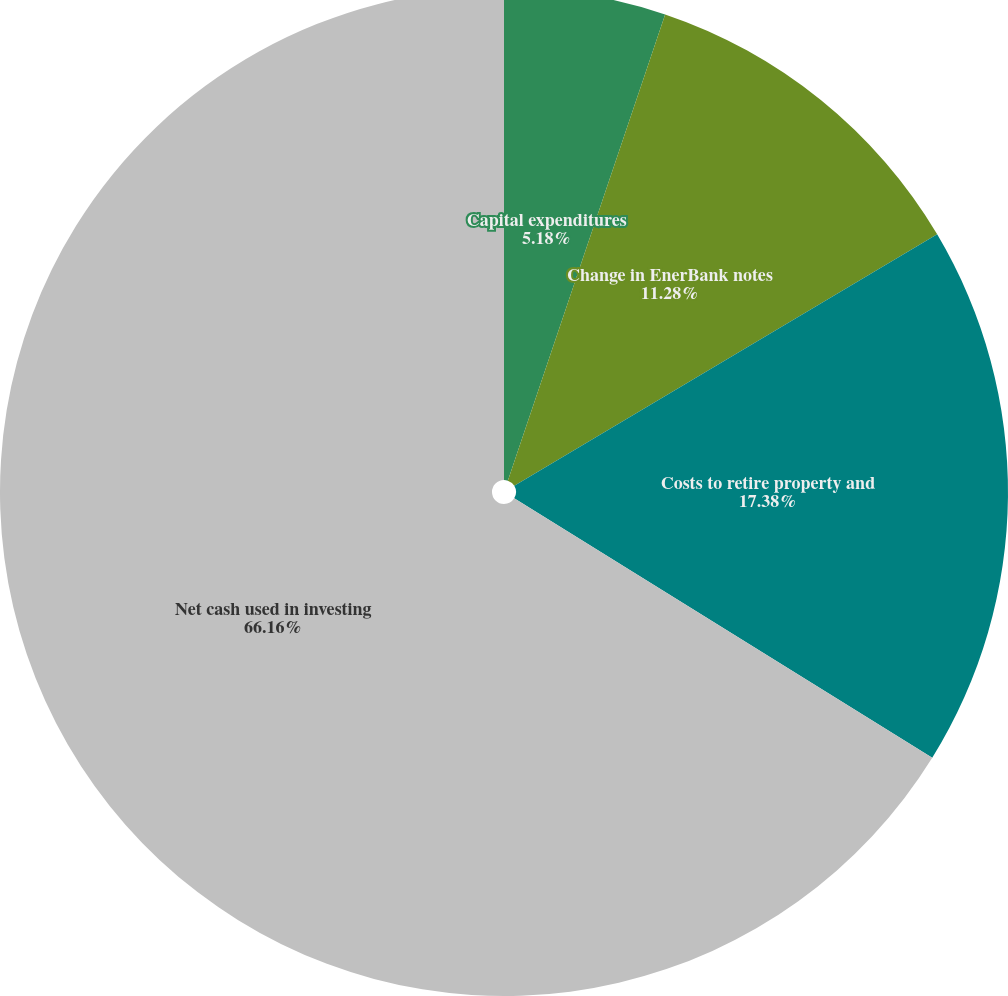<chart> <loc_0><loc_0><loc_500><loc_500><pie_chart><fcel>Capital expenditures<fcel>Change in EnerBank notes<fcel>Costs to retire property and<fcel>Net cash used in investing<nl><fcel>5.18%<fcel>11.28%<fcel>17.38%<fcel>66.16%<nl></chart> 